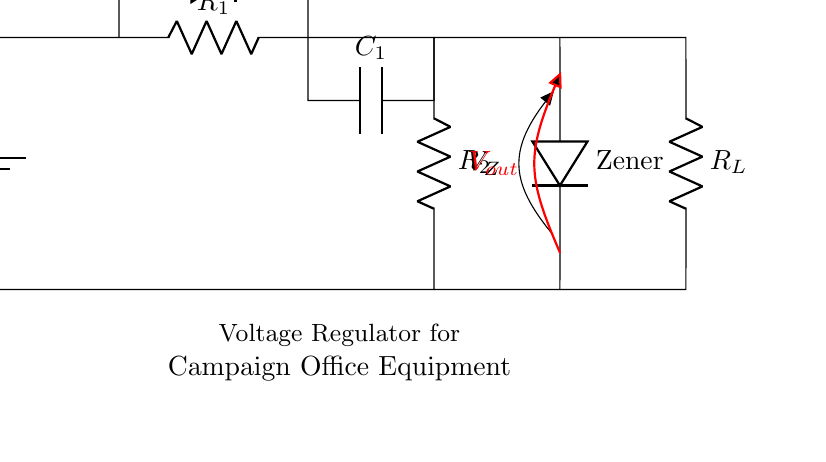What type of components are included in this circuit? The circuit includes resistors, diodes, a capacitor, and a Zener diode. These components are essential for voltage regulation and stabilization in the power supply.
Answer: resistors, diodes, capacitor, Zener diode What does the Zener diode do in this circuit? The Zener diode regulates the output voltage by allowing current to flow in the reverse direction when the voltage exceeds a specified level. This creates a stable reference voltage (V_Z) at the output.
Answer: regulates output voltage What is the purpose of the capacitor in the circuit? The capacitor smooths out fluctuations in the voltage by providing charge storage. It helps to stabilize the voltage delivered to the load (R_L) during varying load conditions.
Answer: smooth voltage fluctuations How is the output voltage obtained from the circuit? The output voltage is measured across the load resistor (R_L). It results from the voltage drop across the Zener diode and is stabilized against fluctuations in the input voltage (V_in).
Answer: across R_L What is the relationship between R_1 and the Zener diode voltage (V_Z)? The resistor R_1 limits the current flowing through the Zener diode, ensuring that it operates within its specified range for maintaining the output voltage (V_Z). If R_1 is too low, the diode may be damaged.
Answer: R_1 limits current What would happen if the load resistance (R_L) is decreased? Decreasing R_L increases the current drawn from the circuit, possibly leading to a drop in output voltage if the current exceeds the limit for stable operation. The Zener diode may also struggle to maintain regulation.
Answer: output voltage drops What is the function of the battery in the circuit? The battery (V_in) provides the initial voltage supply necessary to power the entire circuit, allowing the components to work together to regulate and output a stable voltage.
Answer: power supply 